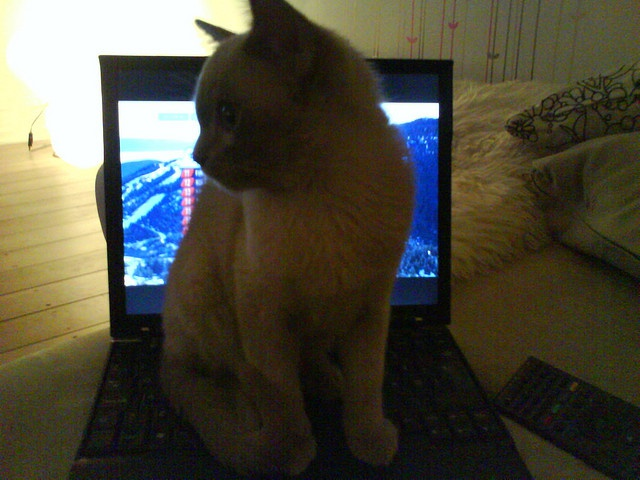Describe the objects in this image and their specific colors. I can see cat in lightyellow, black, maroon, darkgreen, and gray tones, laptop in lightyellow, black, white, blue, and navy tones, bed in lightyellow, black, olive, maroon, and gray tones, and remote in lightyellow, black, navy, maroon, and darkgreen tones in this image. 